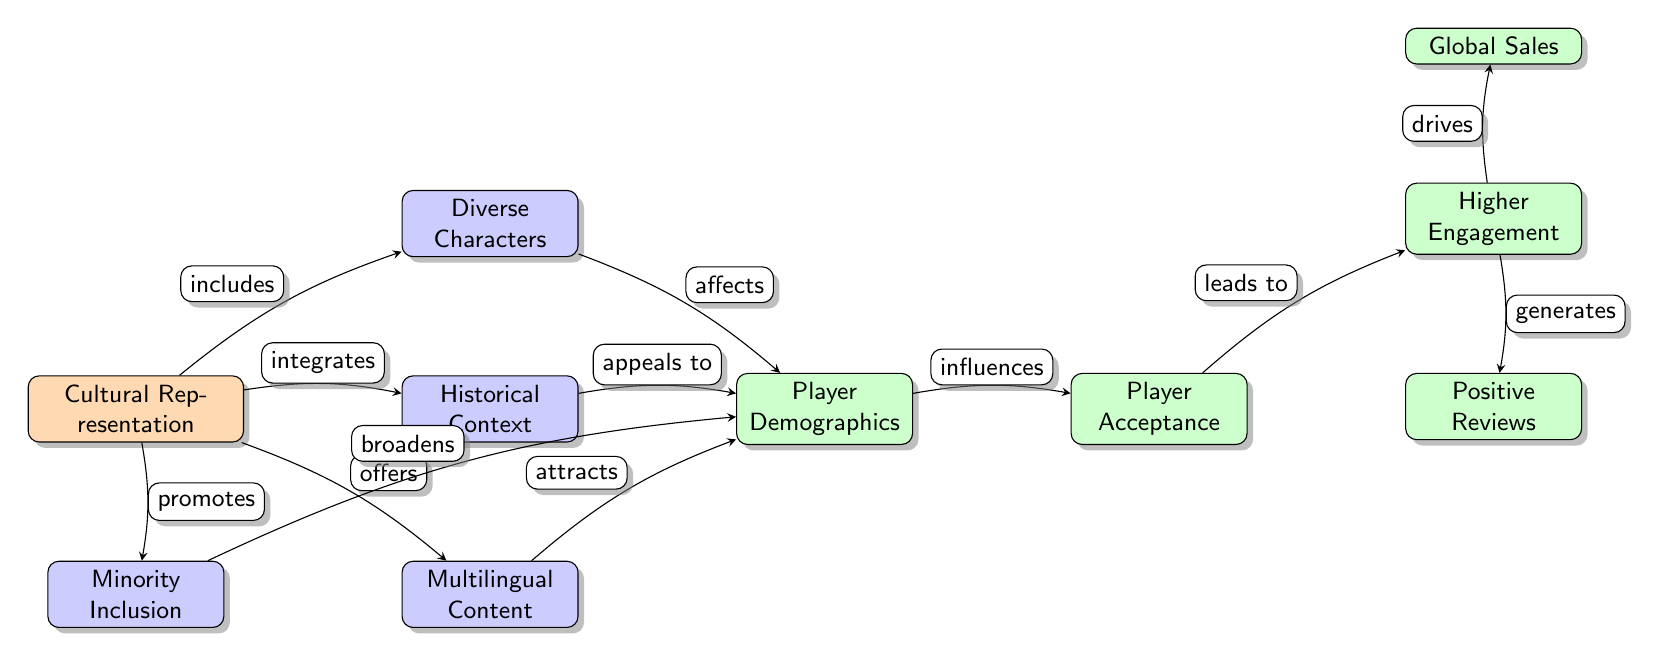What's the main category of the diagram? The main category node is labeled "Cultural Representation," which signifies that the entire diagram revolves around this central concept.
Answer: Cultural Representation How many subcategories are there under "Cultural Representation"? There are four subcategories branching from the main category: "Diverse Characters," "Historical Context," "Multilingual Content," and "Minority Inclusion." Therefore, there are four subcategories.
Answer: 4 What effect does "Diverse Characters" have on "Player Demographics"? The edge labeled "affects" connects "Diverse Characters" to "Player Demographics," indicating that there is a direct influence from diverse characters on player demographics.
Answer: affects Which subcategory leads to "Player Acceptance"? The diagram shows a direct connection between "Player Demographics" and "Player Acceptance," indicating that all subcategories ultimately contribute to player demographics. Hence, their collective ability influences player acceptance.
Answer: Player Demographics What is the final outcome driven by "Higher Engagement"? The diagram indicates two outcomes stemming from "Higher Engagement": "Global Sales" and "Positive Reviews." This shows that higher engagement can lead to these two results.
Answer: Global Sales, Positive Reviews Which subcategory is linked to "affects," "appeals to," and "attracts"? Looking at the edges in the diagram, "Player Demographics" is linked to all these effects: "Diverse Characters" (affects), "Historical Context" (appeals to), and "Multilingual Content" (attracts). These collectively impact demographics.
Answer: Player Demographics What is the importance of "Minority Inclusion" to player demographics? "Minority Inclusion" is positioned to "broaden" player demographics, suggesting it plays a significant role in increasing the representation of various demographics within gaming.
Answer: broadens How does "Player Acceptance" influence "Higher Engagement"? The diagram clearly shows an arrow from "Player Acceptance" leading to "Higher Engagement," indicating that increased acceptance by players can lead to greater engagement with the game content.
Answer: influences Which effect is directly influenced by "Player Demographics"? The effect "Player Acceptance" is directly influenced by "Player Demographics," as indicated by the labeled edge that shows how demographics shape acceptance levels.
Answer: influences 